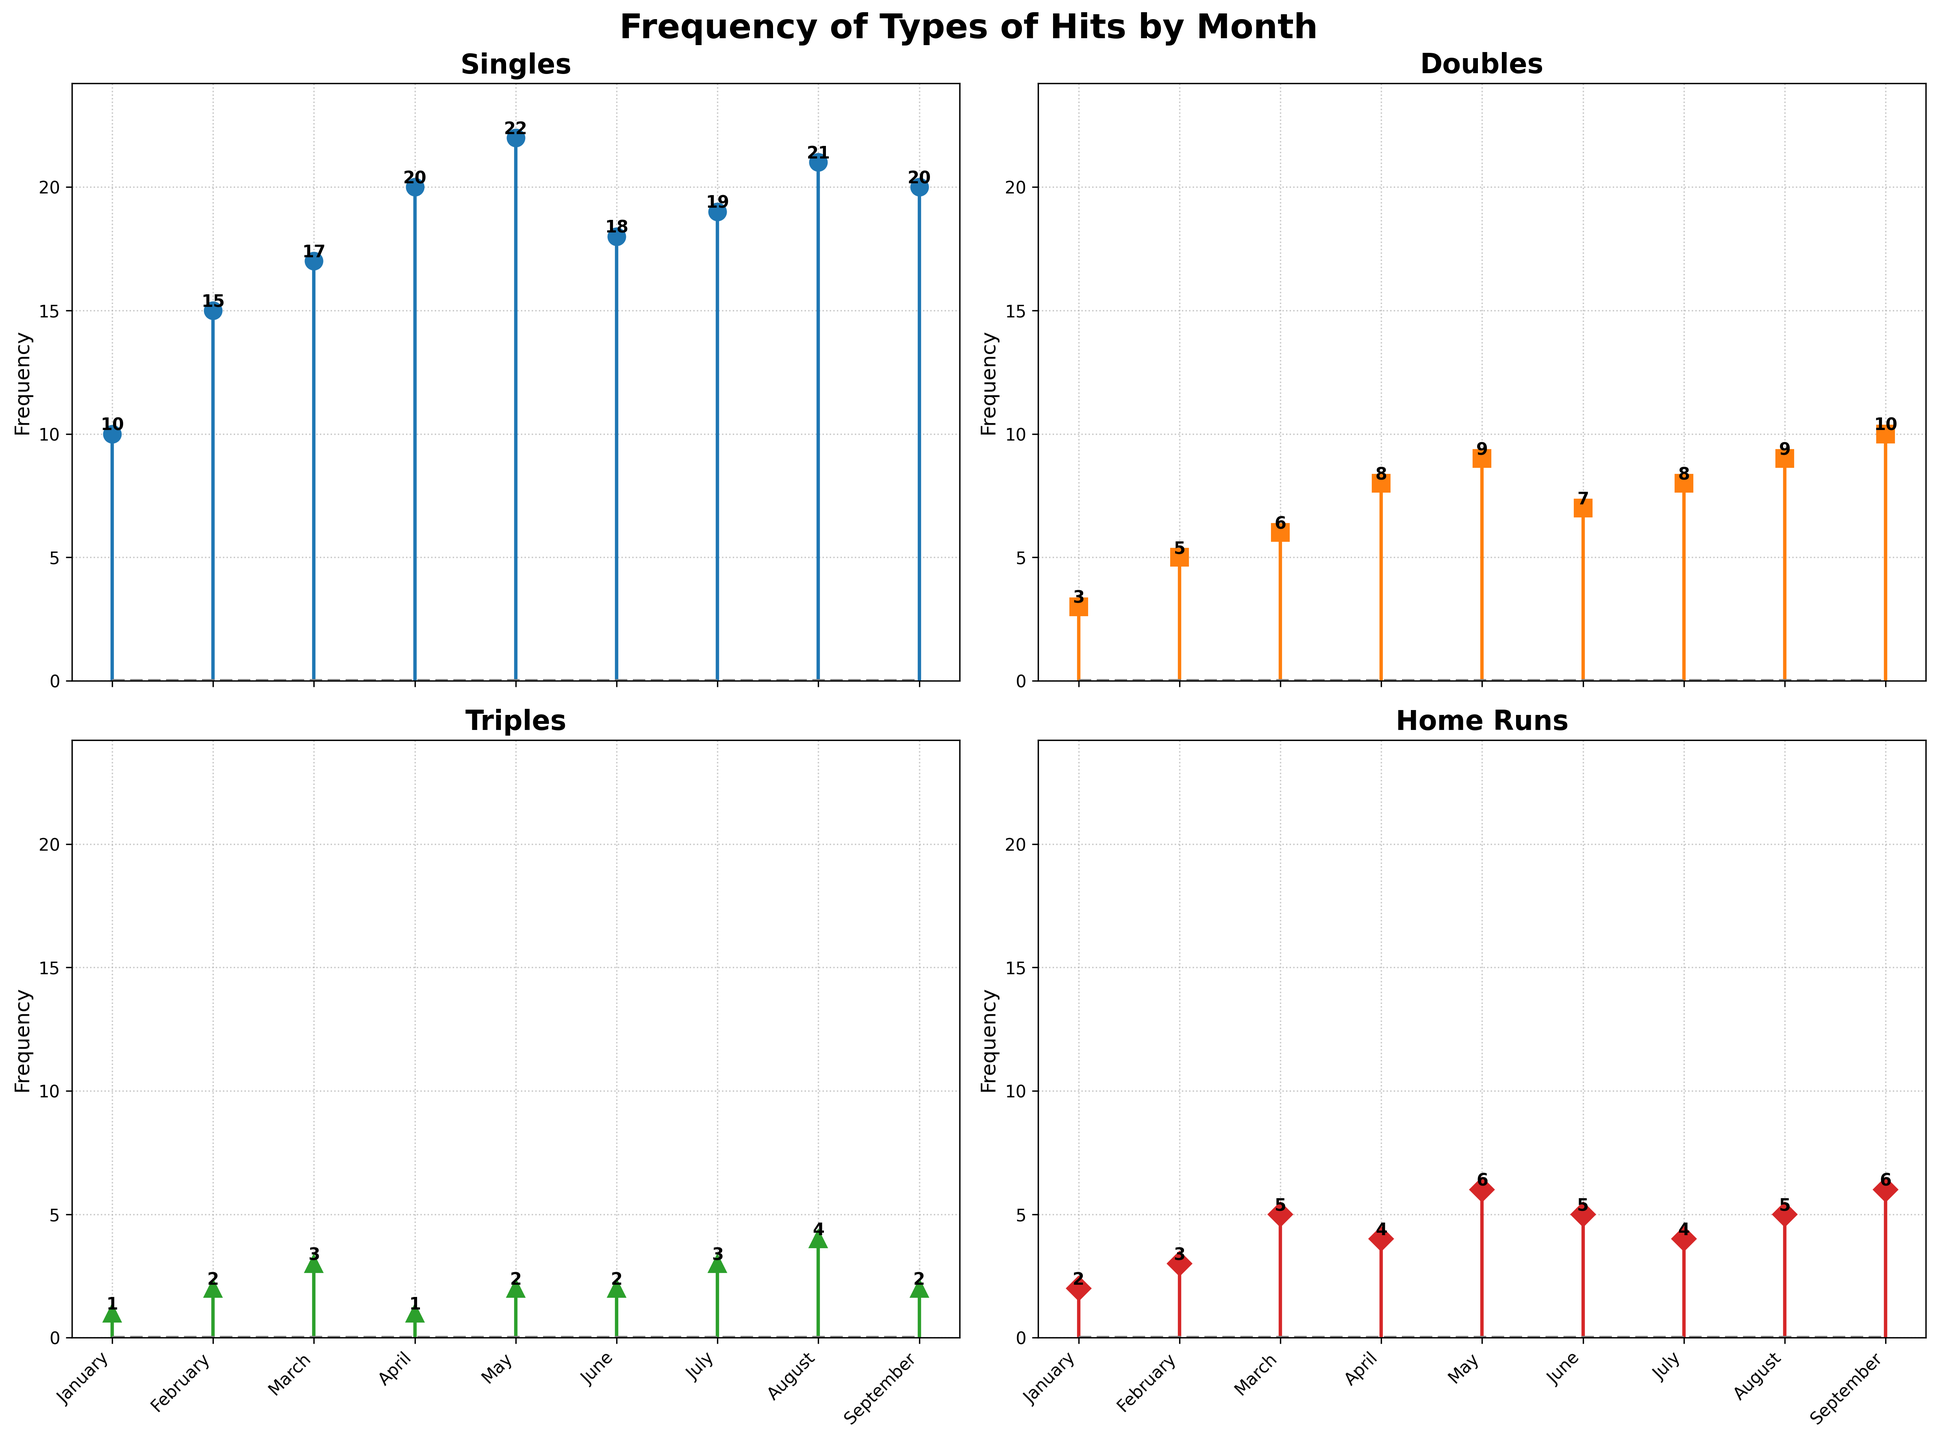Which type of hit had the highest frequency in April? Look at the subplot for April and check the highest stem in terms of frequency. The highest frequency hit type for April is Single with a frequency of 20.
Answer: Single What is the total number of Home Runs from January to March? Identify the Home Run frequencies for January, February, and March (2, 3, and 5 respectively) and then sum them up. So, 2 + 3 + 5 = 10.
Answer: 10 Which month has the lowest number of Triples? Examine the subplot for Triples and look for the shortest stem throughout the months. January and April both have the lowest frequency of 1.
Answer: January and April What is the average frequency of Doubles in the summer months (June to August)? Identify the Double frequencies in June, July, and August (7, 8, and 9 respectively), then calculate the average by summing them up and dividing by 3: (7 + 8 + 9) / 3 = 24 / 3 = 8.
Answer: 8 Are there more singles in May or doubles in September? Compare the frequency of Singles in May (22) with Doubles in September (10). Since 22 > 10, there are more Singles in May.
Answer: Singles in May In which month was the frequency of Singles closest to 20? Look at the subplot for Singles and match the frequencies with the closest value to 20. April, July, and September have frequencies of 20, 19, and 20 respectively, but April and September are exactly 20.
Answer: April and September By how much did the frequency of Home Runs increase from January to May? Identify the frequencies of Home Runs in January and May (2 and 6 respectively), then find the difference: 6 - 2 = 4.
Answer: 4 Which month has the highest frequency of Doubles and what is that frequency? Check the subplot for Doubles and find the tallest stem. September has the highest frequency of 10.
Answer: September, 10 What is the total frequency of all hit types in August? Sum the frequencies of all hit types in August: Single (21), Double (9), Triple (4), Home Run (5). So, 21 + 9 + 4 + 5 = 39.
Answer: 39 